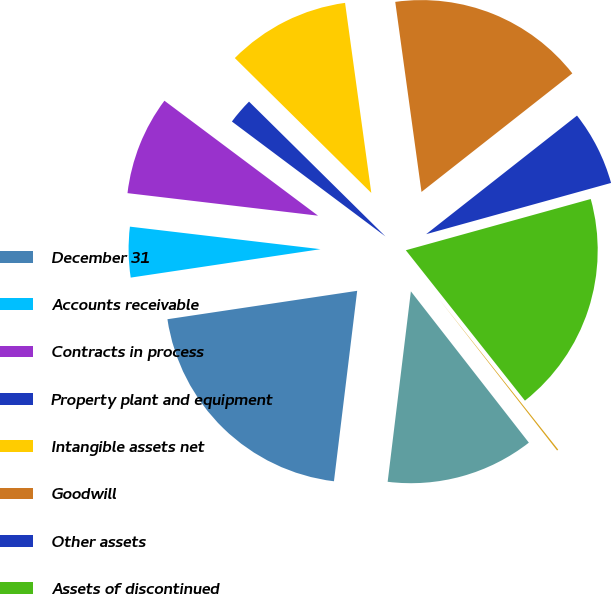<chart> <loc_0><loc_0><loc_500><loc_500><pie_chart><fcel>December 31<fcel>Accounts receivable<fcel>Contracts in process<fcel>Property plant and equipment<fcel>Intangible assets net<fcel>Goodwill<fcel>Other assets<fcel>Assets of discontinued<fcel>Accounts payable<fcel>Other liabilities<nl><fcel>20.7%<fcel>4.24%<fcel>8.35%<fcel>2.18%<fcel>10.41%<fcel>16.58%<fcel>6.3%<fcel>18.64%<fcel>0.12%<fcel>12.47%<nl></chart> 